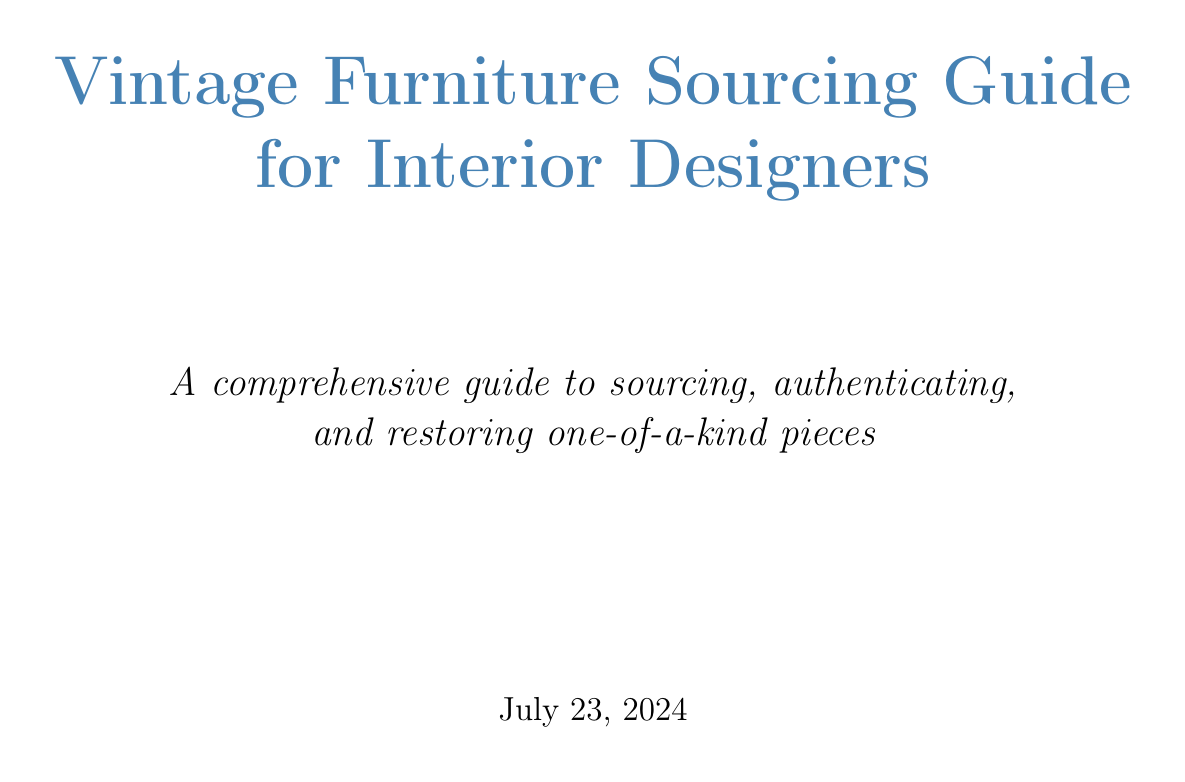What is the title of the guide? The title is clearly stated at the beginning of the document.
Answer: Vintage Furniture Sourcing Guide for Interior Designers What section covers sourcing vintage furniture online? The relevant section is found in the chapter about where to find vintage furniture.
Answer: Online marketplaces (e.g., 1stDibs, Chairish, Etsy) Which chapter discusses working with artisans? This chapter is specifically focused on collaborations and relationships with skilled professionals.
Answer: Working with Artisans and Specialists How many case studies are included in the guide? The total number of case studies is indicated in the respective section of the document.
Answer: Four What is Appendix B about? The content of Appendix B is to provide a specific characteristic overview of certain woods.
Answer: Wood Types and Their Characteristics What is a key reason for restoring vintage furniture instead of preserving it? This reasoning is likely addressed in the restoration chapter focusing on the conditions of the piece.
Answer: When to restore vs. when to preserve Which organization is listed under Professional Associations? The document includes various professional associations related to vintage furniture.
Answer: American Society of Furniture Designers (ASFD) What is the main focus of the chapter on Evaluating Condition and Value? This chapter emphasizes assessing different aspects relevant to vintage furniture condition.
Answer: Assessing structural integrity What year does the vintage furniture styles timeline begin? The timeline presumably starts from a certain historical point as outlined in the appendix.
Answer: 18th century 